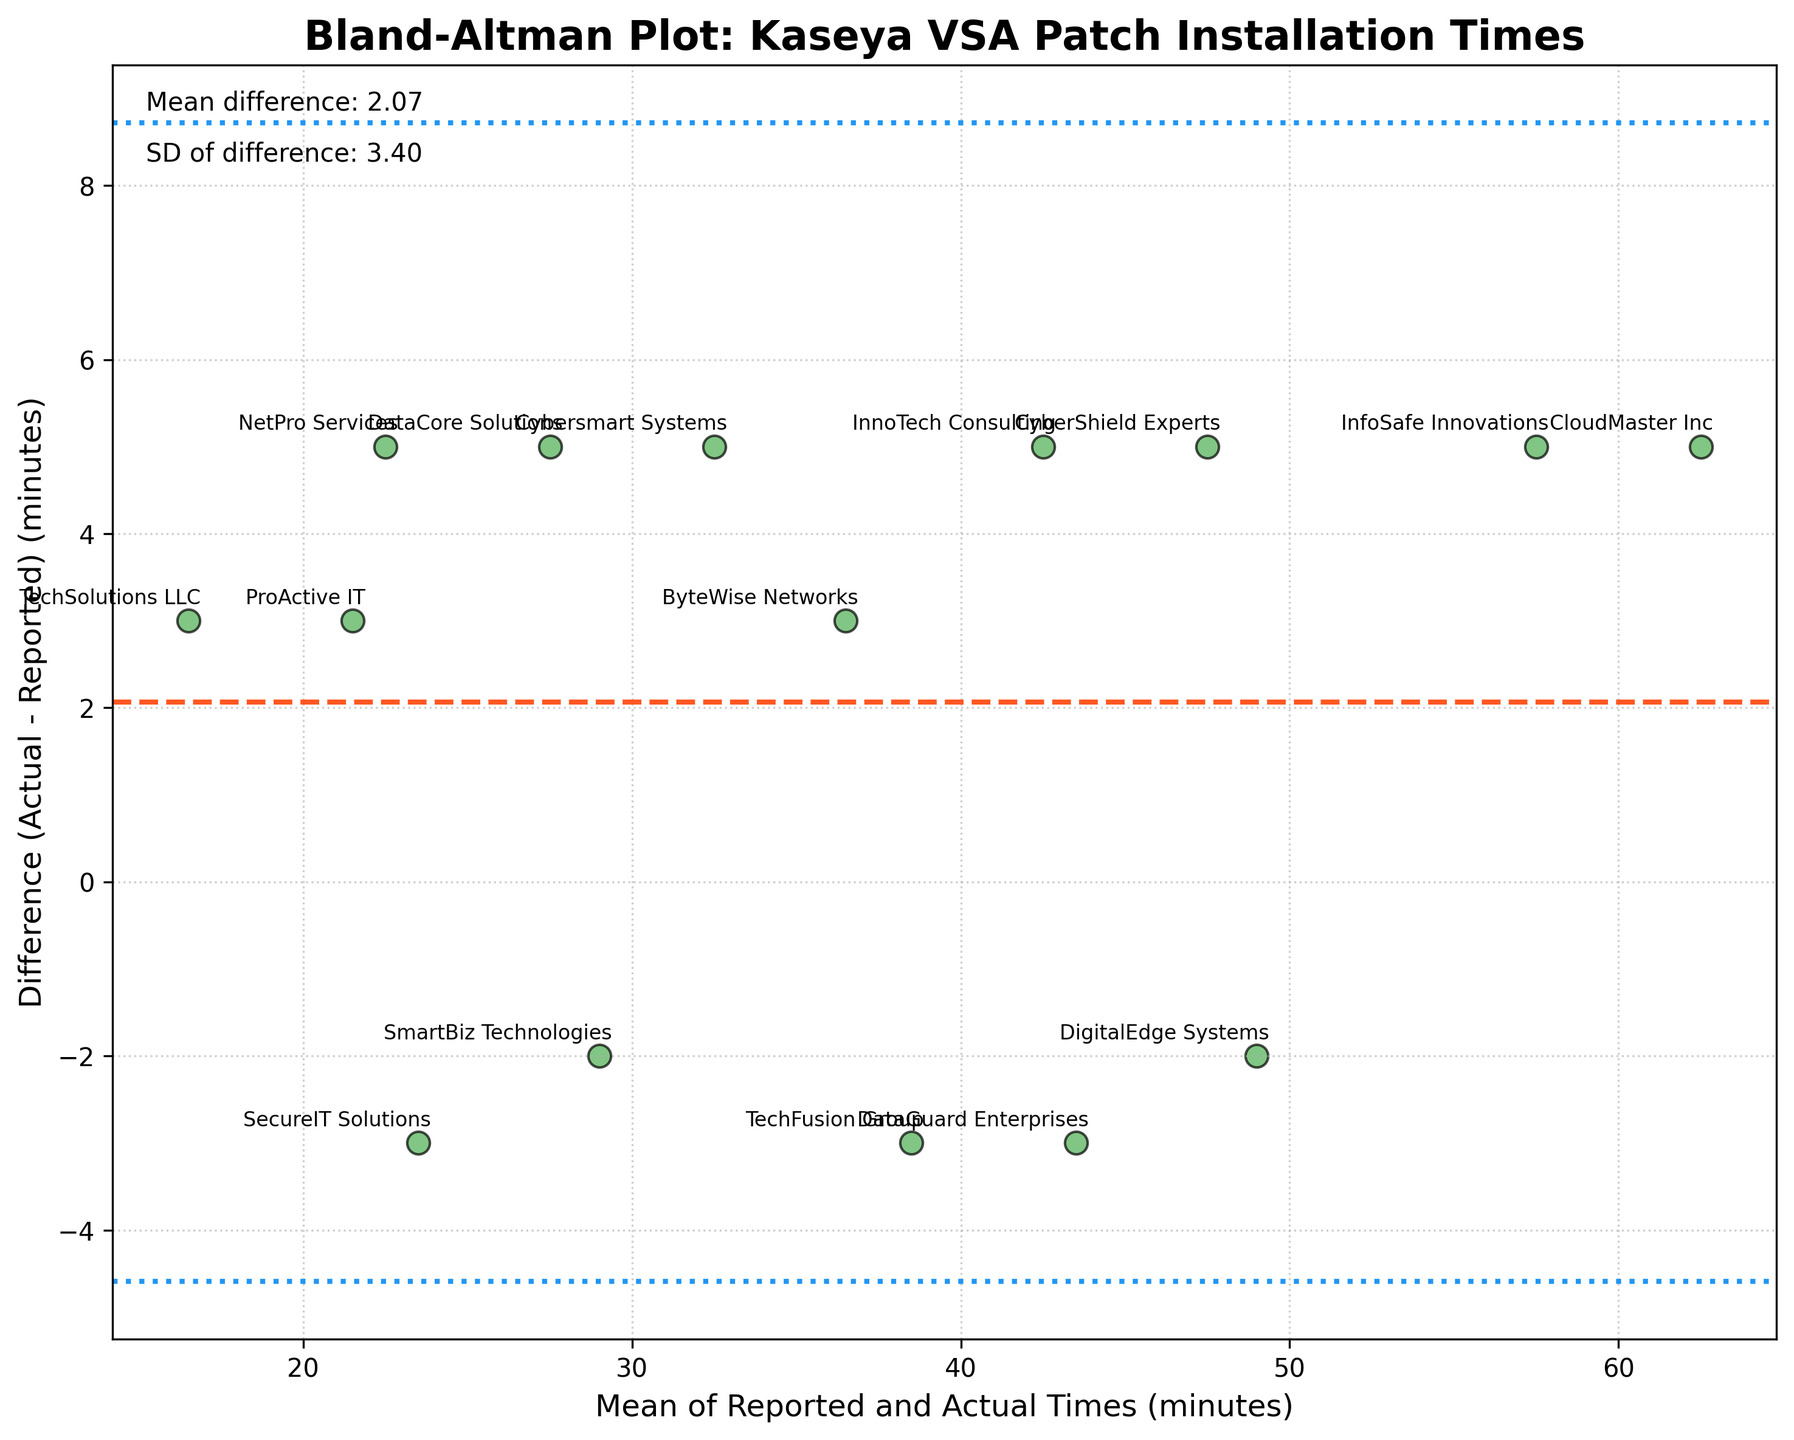What's the title of the figure? The title is usually placed at the top of the figure, and in this case, it reads "Bland-Altman Plot: Kaseya VSA Patch Installation Times".
Answer: Bland-Altman Plot: Kaseya VSA Patch Installation Times How are the data points represented in the plot? The plot uses scatter points to represent data. Each point has a color and specific size, and they appear with a narrow black edge.
Answer: Scatter points What do the horizontal dashed and dotted lines represent? The horizontal dashed line is the mean difference between actual and reported times, and the dotted lines represent the limits of agreement, which are the mean difference plus and minus 1.96 times the standard deviation.
Answer: Mean difference and limits of agreement Which business has the largest discrepancy between reported and actual times? Identify the data point with the largest vertical distance from the mean difference line. In this case, InfoSafe Innovations has one of the most noticeable discrepancies, as seen in the upper right side of the plot.
Answer: InfoSafe Innovations What is the mean of the differences between actual and reported times? This value is annotated on the plot as "Mean difference: X.XX", where X.XX is the numerical value. In the plot, it shows "Mean difference: 2.47".
Answer: 2.47 What are the limits of agreement for the differences? The limits of agreement are annotated lines at specific vertical positions calculated as mean difference ± 1.96 times the SD. In this case, these positions are "Mean difference + 1.96*SD" and "Mean difference - 1.96*SD". The exact values are -0.36 and 5.30.
Answer: -0.36 and 5.30 What is the mean of the reported and actual times for SecureIT Solutions? Locate the point for SecureIT Solutions and determine its position along the x-axis. The reported time is 25, and the actual is 22; hence, the mean is (25+22)/2 = 23.5.
Answer: 23.5 What is the difference (actual - reported) for TechFusion Group? Find the data point for TechFusion Group and determine its vertical position. The reported time is 40, and the actual time is 37; hence, the difference is 37 - 40 = -3.
Answer: -3 Which business has the smallest mean value between reported and actual times? Locate the shortest mean value on the x-axis and identify the business. The shortest mean related to the point at 20.5 is NetPro Services.
Answer: NetPro Services Do any businesses have differences that fall outside the limits of agreement? Compare the vertical positions of data points against the limits of agreement (specified by the dotted lines). In this case, all data points appear within these limit positions.
Answer: No 